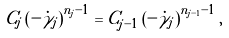<formula> <loc_0><loc_0><loc_500><loc_500>C _ { j } \left ( - \dot { \gamma } _ { j } \right ) ^ { n _ { j } - 1 } = C _ { j - 1 } \left ( - \dot { \gamma } _ { j } \right ) ^ { n _ { j - 1 } - 1 } ,</formula> 